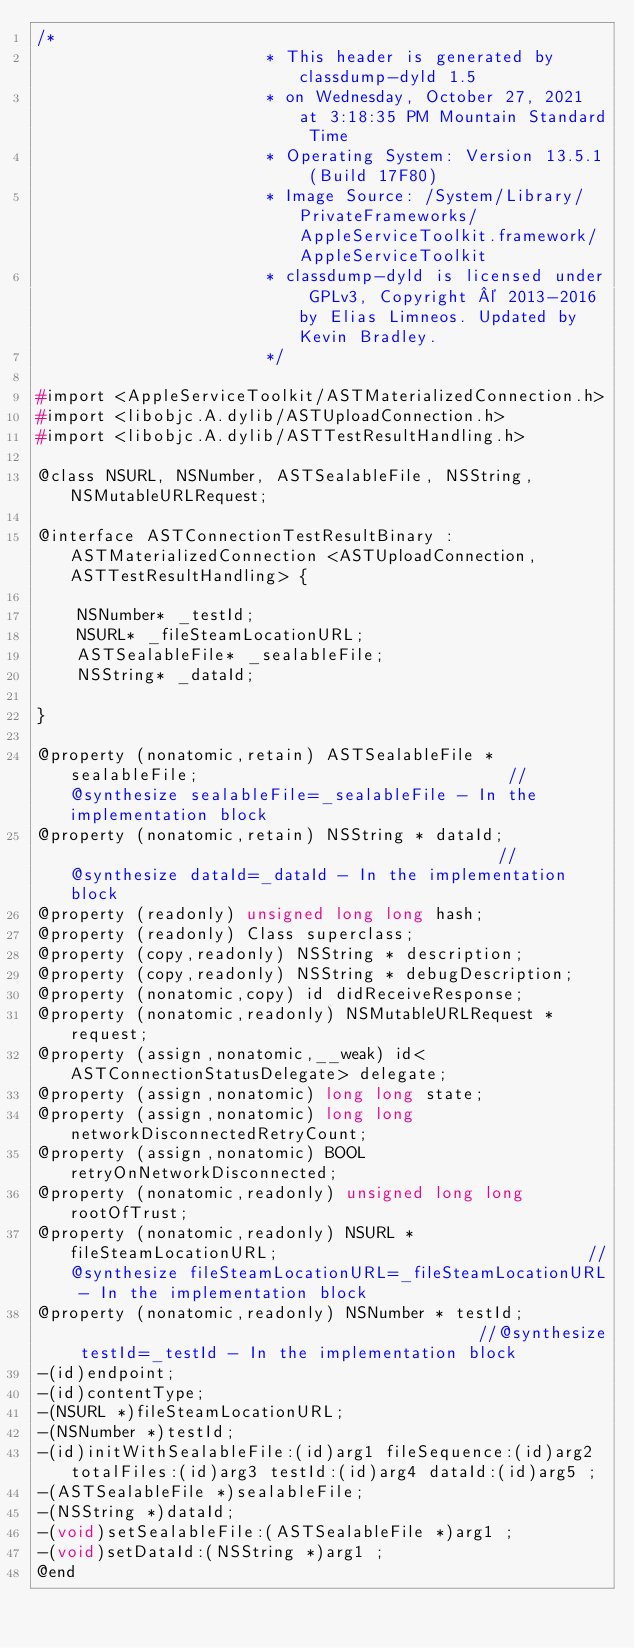<code> <loc_0><loc_0><loc_500><loc_500><_C_>/*
                       * This header is generated by classdump-dyld 1.5
                       * on Wednesday, October 27, 2021 at 3:18:35 PM Mountain Standard Time
                       * Operating System: Version 13.5.1 (Build 17F80)
                       * Image Source: /System/Library/PrivateFrameworks/AppleServiceToolkit.framework/AppleServiceToolkit
                       * classdump-dyld is licensed under GPLv3, Copyright © 2013-2016 by Elias Limneos. Updated by Kevin Bradley.
                       */

#import <AppleServiceToolkit/ASTMaterializedConnection.h>
#import <libobjc.A.dylib/ASTUploadConnection.h>
#import <libobjc.A.dylib/ASTTestResultHandling.h>

@class NSURL, NSNumber, ASTSealableFile, NSString, NSMutableURLRequest;

@interface ASTConnectionTestResultBinary : ASTMaterializedConnection <ASTUploadConnection, ASTTestResultHandling> {

	NSNumber* _testId;
	NSURL* _fileSteamLocationURL;
	ASTSealableFile* _sealableFile;
	NSString* _dataId;

}

@property (nonatomic,retain) ASTSealableFile * sealableFile;                               //@synthesize sealableFile=_sealableFile - In the implementation block
@property (nonatomic,retain) NSString * dataId;                                            //@synthesize dataId=_dataId - In the implementation block
@property (readonly) unsigned long long hash; 
@property (readonly) Class superclass; 
@property (copy,readonly) NSString * description; 
@property (copy,readonly) NSString * debugDescription; 
@property (nonatomic,copy) id didReceiveResponse; 
@property (nonatomic,readonly) NSMutableURLRequest * request; 
@property (assign,nonatomic,__weak) id<ASTConnectionStatusDelegate> delegate; 
@property (assign,nonatomic) long long state; 
@property (assign,nonatomic) long long networkDisconnectedRetryCount; 
@property (assign,nonatomic) BOOL retryOnNetworkDisconnected; 
@property (nonatomic,readonly) unsigned long long rootOfTrust; 
@property (nonatomic,readonly) NSURL * fileSteamLocationURL;                               //@synthesize fileSteamLocationURL=_fileSteamLocationURL - In the implementation block
@property (nonatomic,readonly) NSNumber * testId;                                          //@synthesize testId=_testId - In the implementation block
-(id)endpoint;
-(id)contentType;
-(NSURL *)fileSteamLocationURL;
-(NSNumber *)testId;
-(id)initWithSealableFile:(id)arg1 fileSequence:(id)arg2 totalFiles:(id)arg3 testId:(id)arg4 dataId:(id)arg5 ;
-(ASTSealableFile *)sealableFile;
-(NSString *)dataId;
-(void)setSealableFile:(ASTSealableFile *)arg1 ;
-(void)setDataId:(NSString *)arg1 ;
@end

</code> 